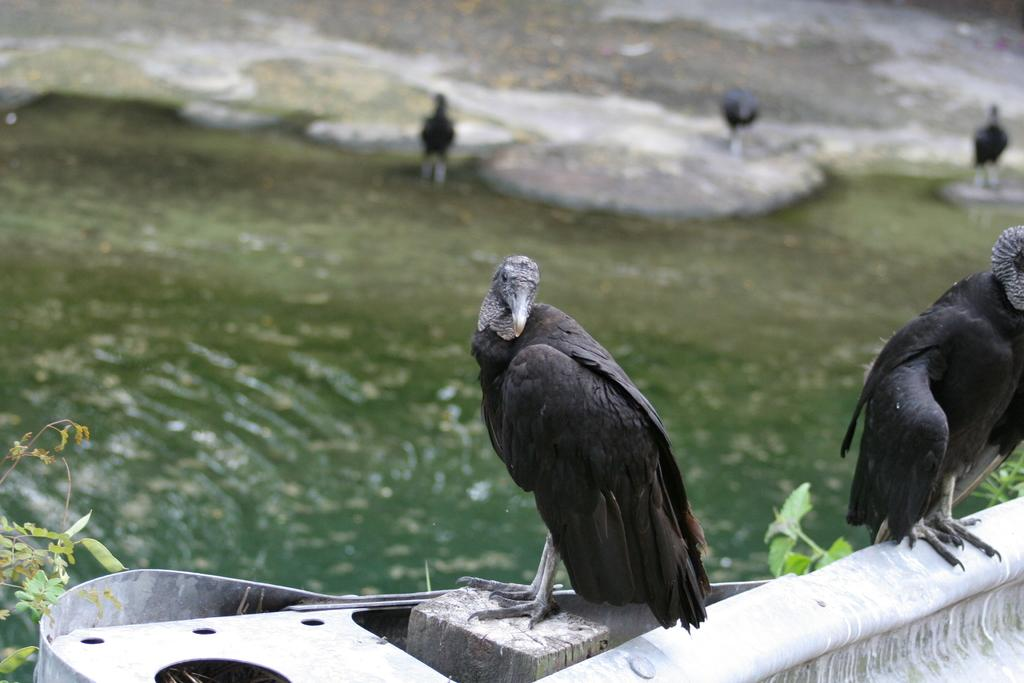What is located in the middle of the image? There is water and eagles in the middle of the image. What type of animals are present in the image? There are eagles in the image. What can be seen on the left side of the image? There are plants on the left side of the image. Can you tell me how many pickles are floating in the water in the image? There are no pickles present in the image; it features water and eagles. What type of pencil is being used by the eagle in the image? There is no pencil present in the image, as it features water and eagles. 